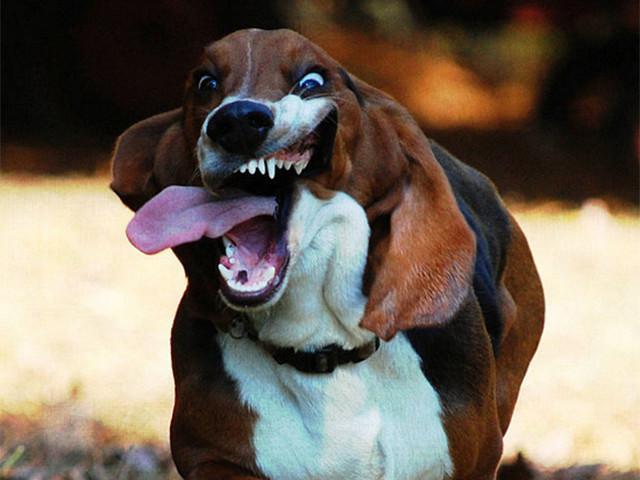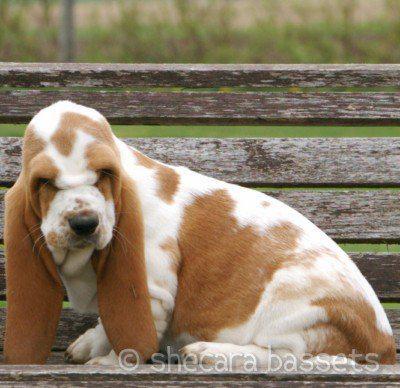The first image is the image on the left, the second image is the image on the right. Assess this claim about the two images: "There are no more than two dogs.". Correct or not? Answer yes or no. Yes. The first image is the image on the left, the second image is the image on the right. Considering the images on both sides, is "The image contains a dog with something in his mouth" valid? Answer yes or no. No. 